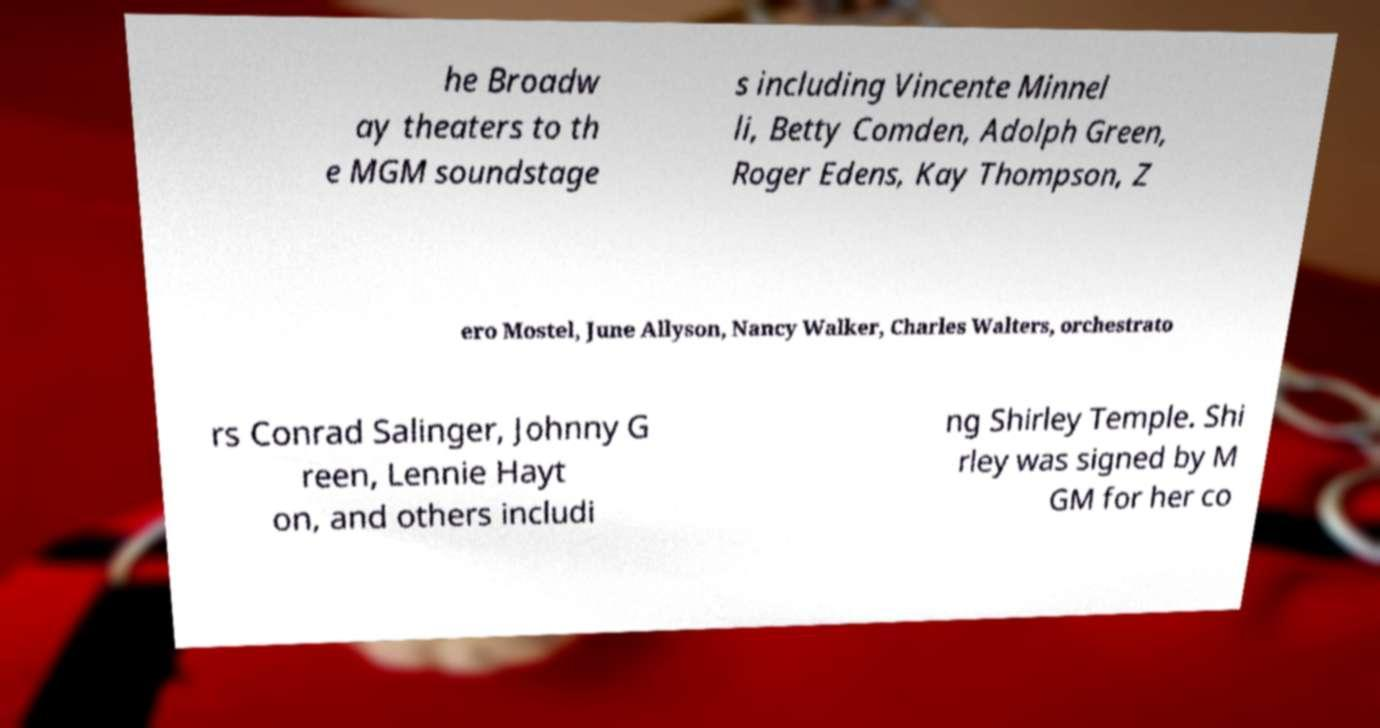Please identify and transcribe the text found in this image. he Broadw ay theaters to th e MGM soundstage s including Vincente Minnel li, Betty Comden, Adolph Green, Roger Edens, Kay Thompson, Z ero Mostel, June Allyson, Nancy Walker, Charles Walters, orchestrato rs Conrad Salinger, Johnny G reen, Lennie Hayt on, and others includi ng Shirley Temple. Shi rley was signed by M GM for her co 